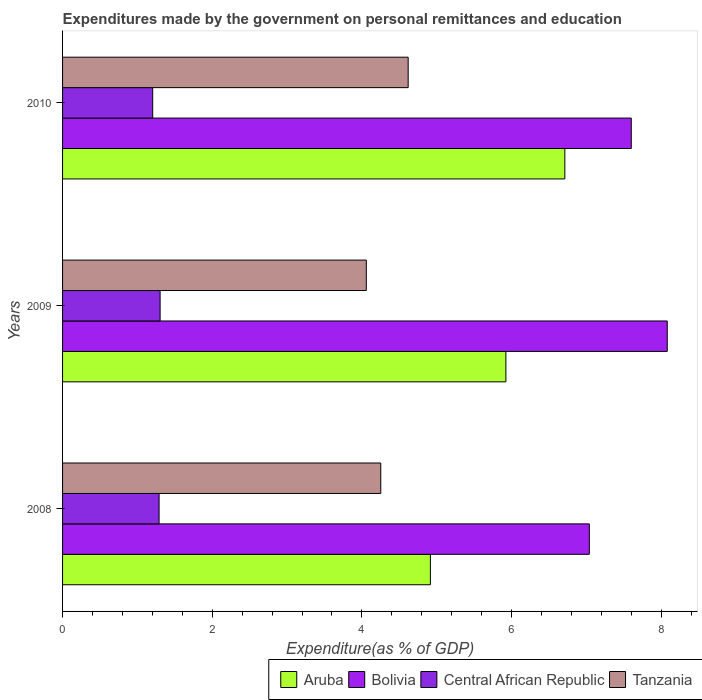What is the expenditures made by the government on personal remittances and education in Central African Republic in 2009?
Offer a very short reply. 1.3. Across all years, what is the maximum expenditures made by the government on personal remittances and education in Tanzania?
Your answer should be compact. 4.62. Across all years, what is the minimum expenditures made by the government on personal remittances and education in Bolivia?
Provide a short and direct response. 7.04. In which year was the expenditures made by the government on personal remittances and education in Tanzania maximum?
Make the answer very short. 2010. What is the total expenditures made by the government on personal remittances and education in Central African Republic in the graph?
Offer a very short reply. 3.8. What is the difference between the expenditures made by the government on personal remittances and education in Bolivia in 2008 and that in 2010?
Provide a short and direct response. -0.56. What is the difference between the expenditures made by the government on personal remittances and education in Tanzania in 2010 and the expenditures made by the government on personal remittances and education in Bolivia in 2009?
Give a very brief answer. -3.46. What is the average expenditures made by the government on personal remittances and education in Aruba per year?
Offer a very short reply. 5.85. In the year 2010, what is the difference between the expenditures made by the government on personal remittances and education in Central African Republic and expenditures made by the government on personal remittances and education in Tanzania?
Make the answer very short. -3.41. In how many years, is the expenditures made by the government on personal remittances and education in Aruba greater than 4 %?
Give a very brief answer. 3. What is the ratio of the expenditures made by the government on personal remittances and education in Central African Republic in 2008 to that in 2009?
Offer a very short reply. 0.99. Is the difference between the expenditures made by the government on personal remittances and education in Central African Republic in 2009 and 2010 greater than the difference between the expenditures made by the government on personal remittances and education in Tanzania in 2009 and 2010?
Make the answer very short. Yes. What is the difference between the highest and the second highest expenditures made by the government on personal remittances and education in Tanzania?
Offer a very short reply. 0.37. What is the difference between the highest and the lowest expenditures made by the government on personal remittances and education in Bolivia?
Offer a terse response. 1.04. In how many years, is the expenditures made by the government on personal remittances and education in Central African Republic greater than the average expenditures made by the government on personal remittances and education in Central African Republic taken over all years?
Your answer should be compact. 2. Is the sum of the expenditures made by the government on personal remittances and education in Central African Republic in 2008 and 2009 greater than the maximum expenditures made by the government on personal remittances and education in Tanzania across all years?
Provide a short and direct response. No. Is it the case that in every year, the sum of the expenditures made by the government on personal remittances and education in Aruba and expenditures made by the government on personal remittances and education in Central African Republic is greater than the sum of expenditures made by the government on personal remittances and education in Bolivia and expenditures made by the government on personal remittances and education in Tanzania?
Offer a terse response. No. What does the 2nd bar from the top in 2010 represents?
Offer a very short reply. Central African Republic. What does the 1st bar from the bottom in 2008 represents?
Your response must be concise. Aruba. Is it the case that in every year, the sum of the expenditures made by the government on personal remittances and education in Central African Republic and expenditures made by the government on personal remittances and education in Aruba is greater than the expenditures made by the government on personal remittances and education in Bolivia?
Provide a succinct answer. No. How many bars are there?
Provide a succinct answer. 12. Are the values on the major ticks of X-axis written in scientific E-notation?
Offer a very short reply. No. Does the graph contain grids?
Your answer should be very brief. No. Where does the legend appear in the graph?
Ensure brevity in your answer.  Bottom right. How many legend labels are there?
Provide a short and direct response. 4. What is the title of the graph?
Your answer should be compact. Expenditures made by the government on personal remittances and education. What is the label or title of the X-axis?
Give a very brief answer. Expenditure(as % of GDP). What is the Expenditure(as % of GDP) in Aruba in 2008?
Make the answer very short. 4.92. What is the Expenditure(as % of GDP) of Bolivia in 2008?
Offer a terse response. 7.04. What is the Expenditure(as % of GDP) of Central African Republic in 2008?
Provide a succinct answer. 1.29. What is the Expenditure(as % of GDP) in Tanzania in 2008?
Your answer should be very brief. 4.25. What is the Expenditure(as % of GDP) of Aruba in 2009?
Provide a succinct answer. 5.92. What is the Expenditure(as % of GDP) of Bolivia in 2009?
Provide a short and direct response. 8.08. What is the Expenditure(as % of GDP) in Central African Republic in 2009?
Provide a short and direct response. 1.3. What is the Expenditure(as % of GDP) of Tanzania in 2009?
Provide a short and direct response. 4.06. What is the Expenditure(as % of GDP) in Aruba in 2010?
Provide a succinct answer. 6.71. What is the Expenditure(as % of GDP) of Bolivia in 2010?
Ensure brevity in your answer.  7.6. What is the Expenditure(as % of GDP) of Central African Republic in 2010?
Your answer should be very brief. 1.2. What is the Expenditure(as % of GDP) of Tanzania in 2010?
Offer a very short reply. 4.62. Across all years, what is the maximum Expenditure(as % of GDP) of Aruba?
Offer a terse response. 6.71. Across all years, what is the maximum Expenditure(as % of GDP) in Bolivia?
Ensure brevity in your answer.  8.08. Across all years, what is the maximum Expenditure(as % of GDP) of Central African Republic?
Give a very brief answer. 1.3. Across all years, what is the maximum Expenditure(as % of GDP) of Tanzania?
Keep it short and to the point. 4.62. Across all years, what is the minimum Expenditure(as % of GDP) in Aruba?
Your response must be concise. 4.92. Across all years, what is the minimum Expenditure(as % of GDP) in Bolivia?
Your answer should be compact. 7.04. Across all years, what is the minimum Expenditure(as % of GDP) of Central African Republic?
Give a very brief answer. 1.2. Across all years, what is the minimum Expenditure(as % of GDP) of Tanzania?
Your answer should be very brief. 4.06. What is the total Expenditure(as % of GDP) of Aruba in the graph?
Make the answer very short. 17.55. What is the total Expenditure(as % of GDP) in Bolivia in the graph?
Your response must be concise. 22.72. What is the total Expenditure(as % of GDP) of Central African Republic in the graph?
Give a very brief answer. 3.8. What is the total Expenditure(as % of GDP) of Tanzania in the graph?
Provide a succinct answer. 12.93. What is the difference between the Expenditure(as % of GDP) in Aruba in 2008 and that in 2009?
Provide a succinct answer. -1.01. What is the difference between the Expenditure(as % of GDP) in Bolivia in 2008 and that in 2009?
Offer a terse response. -1.04. What is the difference between the Expenditure(as % of GDP) in Central African Republic in 2008 and that in 2009?
Provide a succinct answer. -0.01. What is the difference between the Expenditure(as % of GDP) in Tanzania in 2008 and that in 2009?
Provide a short and direct response. 0.19. What is the difference between the Expenditure(as % of GDP) of Aruba in 2008 and that in 2010?
Ensure brevity in your answer.  -1.8. What is the difference between the Expenditure(as % of GDP) in Bolivia in 2008 and that in 2010?
Ensure brevity in your answer.  -0.56. What is the difference between the Expenditure(as % of GDP) in Central African Republic in 2008 and that in 2010?
Your answer should be compact. 0.09. What is the difference between the Expenditure(as % of GDP) in Tanzania in 2008 and that in 2010?
Give a very brief answer. -0.37. What is the difference between the Expenditure(as % of GDP) of Aruba in 2009 and that in 2010?
Ensure brevity in your answer.  -0.79. What is the difference between the Expenditure(as % of GDP) in Bolivia in 2009 and that in 2010?
Offer a terse response. 0.48. What is the difference between the Expenditure(as % of GDP) in Central African Republic in 2009 and that in 2010?
Give a very brief answer. 0.1. What is the difference between the Expenditure(as % of GDP) of Tanzania in 2009 and that in 2010?
Your response must be concise. -0.56. What is the difference between the Expenditure(as % of GDP) of Aruba in 2008 and the Expenditure(as % of GDP) of Bolivia in 2009?
Offer a terse response. -3.17. What is the difference between the Expenditure(as % of GDP) in Aruba in 2008 and the Expenditure(as % of GDP) in Central African Republic in 2009?
Provide a succinct answer. 3.61. What is the difference between the Expenditure(as % of GDP) in Aruba in 2008 and the Expenditure(as % of GDP) in Tanzania in 2009?
Your answer should be very brief. 0.86. What is the difference between the Expenditure(as % of GDP) of Bolivia in 2008 and the Expenditure(as % of GDP) of Central African Republic in 2009?
Ensure brevity in your answer.  5.74. What is the difference between the Expenditure(as % of GDP) of Bolivia in 2008 and the Expenditure(as % of GDP) of Tanzania in 2009?
Your answer should be very brief. 2.98. What is the difference between the Expenditure(as % of GDP) of Central African Republic in 2008 and the Expenditure(as % of GDP) of Tanzania in 2009?
Your response must be concise. -2.77. What is the difference between the Expenditure(as % of GDP) in Aruba in 2008 and the Expenditure(as % of GDP) in Bolivia in 2010?
Offer a very short reply. -2.68. What is the difference between the Expenditure(as % of GDP) in Aruba in 2008 and the Expenditure(as % of GDP) in Central African Republic in 2010?
Offer a terse response. 3.71. What is the difference between the Expenditure(as % of GDP) of Aruba in 2008 and the Expenditure(as % of GDP) of Tanzania in 2010?
Your response must be concise. 0.3. What is the difference between the Expenditure(as % of GDP) in Bolivia in 2008 and the Expenditure(as % of GDP) in Central African Republic in 2010?
Your answer should be compact. 5.84. What is the difference between the Expenditure(as % of GDP) in Bolivia in 2008 and the Expenditure(as % of GDP) in Tanzania in 2010?
Your response must be concise. 2.42. What is the difference between the Expenditure(as % of GDP) of Central African Republic in 2008 and the Expenditure(as % of GDP) of Tanzania in 2010?
Keep it short and to the point. -3.33. What is the difference between the Expenditure(as % of GDP) of Aruba in 2009 and the Expenditure(as % of GDP) of Bolivia in 2010?
Your answer should be very brief. -1.68. What is the difference between the Expenditure(as % of GDP) in Aruba in 2009 and the Expenditure(as % of GDP) in Central African Republic in 2010?
Give a very brief answer. 4.72. What is the difference between the Expenditure(as % of GDP) of Aruba in 2009 and the Expenditure(as % of GDP) of Tanzania in 2010?
Offer a very short reply. 1.31. What is the difference between the Expenditure(as % of GDP) in Bolivia in 2009 and the Expenditure(as % of GDP) in Central African Republic in 2010?
Offer a very short reply. 6.88. What is the difference between the Expenditure(as % of GDP) in Bolivia in 2009 and the Expenditure(as % of GDP) in Tanzania in 2010?
Your answer should be very brief. 3.46. What is the difference between the Expenditure(as % of GDP) in Central African Republic in 2009 and the Expenditure(as % of GDP) in Tanzania in 2010?
Your answer should be compact. -3.32. What is the average Expenditure(as % of GDP) of Aruba per year?
Offer a terse response. 5.85. What is the average Expenditure(as % of GDP) of Bolivia per year?
Your answer should be compact. 7.57. What is the average Expenditure(as % of GDP) of Central African Republic per year?
Provide a succinct answer. 1.27. What is the average Expenditure(as % of GDP) in Tanzania per year?
Offer a very short reply. 4.31. In the year 2008, what is the difference between the Expenditure(as % of GDP) of Aruba and Expenditure(as % of GDP) of Bolivia?
Your answer should be very brief. -2.12. In the year 2008, what is the difference between the Expenditure(as % of GDP) of Aruba and Expenditure(as % of GDP) of Central African Republic?
Your answer should be compact. 3.63. In the year 2008, what is the difference between the Expenditure(as % of GDP) in Aruba and Expenditure(as % of GDP) in Tanzania?
Offer a very short reply. 0.66. In the year 2008, what is the difference between the Expenditure(as % of GDP) of Bolivia and Expenditure(as % of GDP) of Central African Republic?
Offer a terse response. 5.75. In the year 2008, what is the difference between the Expenditure(as % of GDP) in Bolivia and Expenditure(as % of GDP) in Tanzania?
Provide a succinct answer. 2.79. In the year 2008, what is the difference between the Expenditure(as % of GDP) in Central African Republic and Expenditure(as % of GDP) in Tanzania?
Provide a succinct answer. -2.96. In the year 2009, what is the difference between the Expenditure(as % of GDP) in Aruba and Expenditure(as % of GDP) in Bolivia?
Your answer should be compact. -2.16. In the year 2009, what is the difference between the Expenditure(as % of GDP) in Aruba and Expenditure(as % of GDP) in Central African Republic?
Give a very brief answer. 4.62. In the year 2009, what is the difference between the Expenditure(as % of GDP) in Aruba and Expenditure(as % of GDP) in Tanzania?
Your response must be concise. 1.87. In the year 2009, what is the difference between the Expenditure(as % of GDP) of Bolivia and Expenditure(as % of GDP) of Central African Republic?
Make the answer very short. 6.78. In the year 2009, what is the difference between the Expenditure(as % of GDP) of Bolivia and Expenditure(as % of GDP) of Tanzania?
Your response must be concise. 4.02. In the year 2009, what is the difference between the Expenditure(as % of GDP) in Central African Republic and Expenditure(as % of GDP) in Tanzania?
Your response must be concise. -2.76. In the year 2010, what is the difference between the Expenditure(as % of GDP) in Aruba and Expenditure(as % of GDP) in Bolivia?
Provide a short and direct response. -0.89. In the year 2010, what is the difference between the Expenditure(as % of GDP) in Aruba and Expenditure(as % of GDP) in Central African Republic?
Offer a very short reply. 5.51. In the year 2010, what is the difference between the Expenditure(as % of GDP) in Aruba and Expenditure(as % of GDP) in Tanzania?
Your answer should be compact. 2.09. In the year 2010, what is the difference between the Expenditure(as % of GDP) in Bolivia and Expenditure(as % of GDP) in Central African Republic?
Ensure brevity in your answer.  6.4. In the year 2010, what is the difference between the Expenditure(as % of GDP) in Bolivia and Expenditure(as % of GDP) in Tanzania?
Make the answer very short. 2.98. In the year 2010, what is the difference between the Expenditure(as % of GDP) in Central African Republic and Expenditure(as % of GDP) in Tanzania?
Your response must be concise. -3.41. What is the ratio of the Expenditure(as % of GDP) of Aruba in 2008 to that in 2009?
Offer a very short reply. 0.83. What is the ratio of the Expenditure(as % of GDP) in Bolivia in 2008 to that in 2009?
Provide a short and direct response. 0.87. What is the ratio of the Expenditure(as % of GDP) in Central African Republic in 2008 to that in 2009?
Provide a succinct answer. 0.99. What is the ratio of the Expenditure(as % of GDP) of Tanzania in 2008 to that in 2009?
Provide a succinct answer. 1.05. What is the ratio of the Expenditure(as % of GDP) in Aruba in 2008 to that in 2010?
Your response must be concise. 0.73. What is the ratio of the Expenditure(as % of GDP) in Bolivia in 2008 to that in 2010?
Your answer should be compact. 0.93. What is the ratio of the Expenditure(as % of GDP) of Central African Republic in 2008 to that in 2010?
Offer a terse response. 1.07. What is the ratio of the Expenditure(as % of GDP) in Tanzania in 2008 to that in 2010?
Offer a terse response. 0.92. What is the ratio of the Expenditure(as % of GDP) of Aruba in 2009 to that in 2010?
Give a very brief answer. 0.88. What is the ratio of the Expenditure(as % of GDP) of Bolivia in 2009 to that in 2010?
Ensure brevity in your answer.  1.06. What is the ratio of the Expenditure(as % of GDP) in Central African Republic in 2009 to that in 2010?
Keep it short and to the point. 1.08. What is the ratio of the Expenditure(as % of GDP) of Tanzania in 2009 to that in 2010?
Offer a terse response. 0.88. What is the difference between the highest and the second highest Expenditure(as % of GDP) of Aruba?
Offer a terse response. 0.79. What is the difference between the highest and the second highest Expenditure(as % of GDP) in Bolivia?
Keep it short and to the point. 0.48. What is the difference between the highest and the second highest Expenditure(as % of GDP) in Central African Republic?
Offer a very short reply. 0.01. What is the difference between the highest and the second highest Expenditure(as % of GDP) of Tanzania?
Ensure brevity in your answer.  0.37. What is the difference between the highest and the lowest Expenditure(as % of GDP) in Aruba?
Your answer should be compact. 1.8. What is the difference between the highest and the lowest Expenditure(as % of GDP) of Bolivia?
Make the answer very short. 1.04. What is the difference between the highest and the lowest Expenditure(as % of GDP) in Central African Republic?
Provide a short and direct response. 0.1. What is the difference between the highest and the lowest Expenditure(as % of GDP) in Tanzania?
Provide a short and direct response. 0.56. 